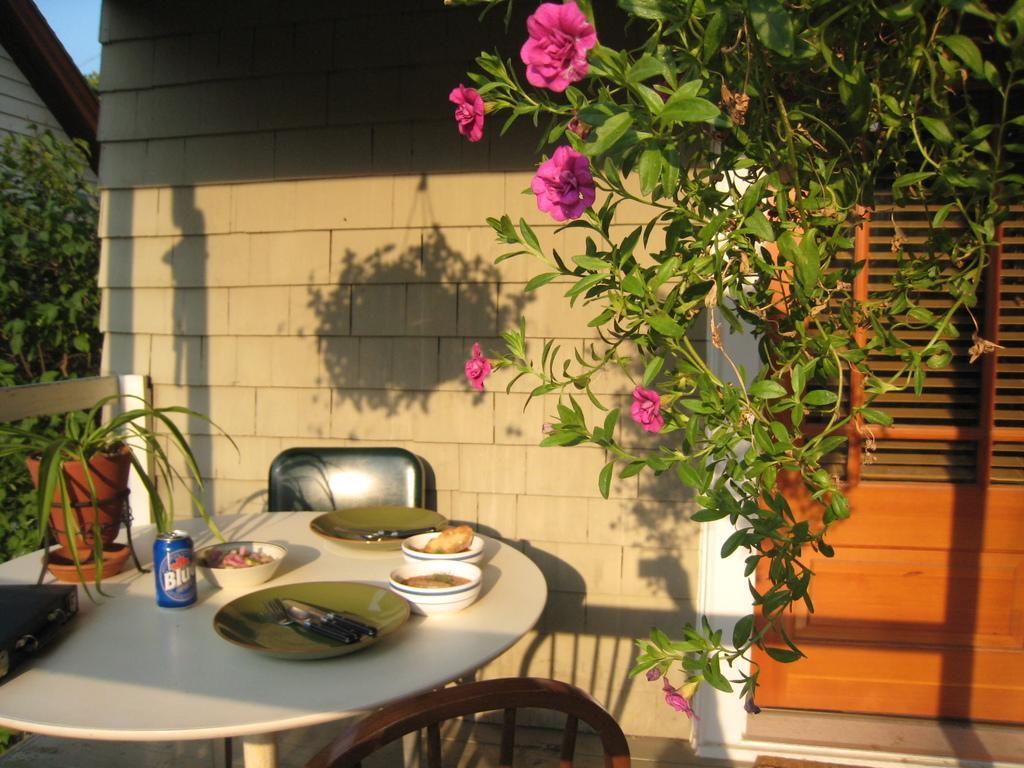Please provide a concise description of this image. In the image in the center we can see the table. On table we can see the plate,knife,can,plant pot etc. And they were two chairs around table. And on the right top we can see one plant with some flowers. Coming to the background we can see the wall and building and trees. 